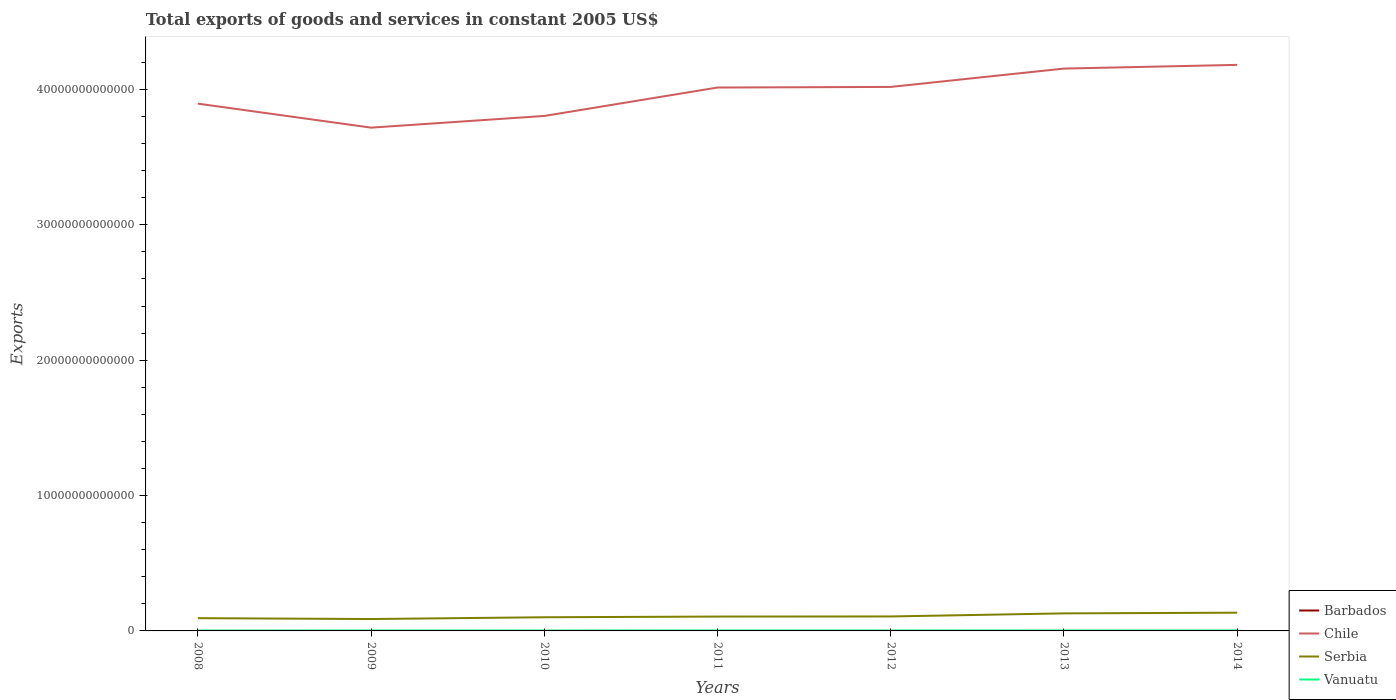Does the line corresponding to Vanuatu intersect with the line corresponding to Barbados?
Provide a short and direct response. No. Is the number of lines equal to the number of legend labels?
Offer a terse response. Yes. Across all years, what is the maximum total exports of goods and services in Barbados?
Make the answer very short. 5.80e+08. In which year was the total exports of goods and services in Barbados maximum?
Provide a short and direct response. 2013. What is the total total exports of goods and services in Barbados in the graph?
Provide a succinct answer. 1.68e+08. What is the difference between the highest and the second highest total exports of goods and services in Chile?
Your answer should be compact. 4.64e+12. Is the total exports of goods and services in Vanuatu strictly greater than the total exports of goods and services in Serbia over the years?
Offer a very short reply. Yes. How many lines are there?
Ensure brevity in your answer.  4. How many years are there in the graph?
Your answer should be compact. 7. What is the difference between two consecutive major ticks on the Y-axis?
Ensure brevity in your answer.  1.00e+13. How many legend labels are there?
Provide a short and direct response. 4. What is the title of the graph?
Your answer should be compact. Total exports of goods and services in constant 2005 US$. Does "Least developed countries" appear as one of the legend labels in the graph?
Give a very brief answer. No. What is the label or title of the Y-axis?
Your response must be concise. Exports. What is the Exports of Barbados in 2008?
Your response must be concise. 7.82e+08. What is the Exports of Chile in 2008?
Make the answer very short. 3.90e+13. What is the Exports of Serbia in 2008?
Provide a succinct answer. 9.43e+11. What is the Exports in Vanuatu in 2008?
Your answer should be very brief. 2.31e+1. What is the Exports in Barbados in 2009?
Ensure brevity in your answer.  7.59e+08. What is the Exports of Chile in 2009?
Offer a terse response. 3.72e+13. What is the Exports of Serbia in 2009?
Offer a terse response. 8.78e+11. What is the Exports of Vanuatu in 2009?
Offer a terse response. 2.64e+1. What is the Exports in Barbados in 2010?
Offer a terse response. 7.95e+08. What is the Exports in Chile in 2010?
Make the answer very short. 3.80e+13. What is the Exports in Serbia in 2010?
Make the answer very short. 1.01e+12. What is the Exports in Vanuatu in 2010?
Offer a very short reply. 2.65e+1. What is the Exports of Barbados in 2011?
Your answer should be compact. 6.14e+08. What is the Exports of Chile in 2011?
Provide a succinct answer. 4.01e+13. What is the Exports in Serbia in 2011?
Give a very brief answer. 1.06e+12. What is the Exports in Vanuatu in 2011?
Your response must be concise. 2.92e+1. What is the Exports in Barbados in 2012?
Your answer should be very brief. 6.13e+08. What is the Exports in Chile in 2012?
Give a very brief answer. 4.02e+13. What is the Exports of Serbia in 2012?
Ensure brevity in your answer.  1.07e+12. What is the Exports in Vanuatu in 2012?
Offer a terse response. 2.89e+1. What is the Exports in Barbados in 2013?
Provide a succinct answer. 5.80e+08. What is the Exports of Chile in 2013?
Your answer should be very brief. 4.15e+13. What is the Exports in Serbia in 2013?
Give a very brief answer. 1.30e+12. What is the Exports in Vanuatu in 2013?
Make the answer very short. 3.01e+1. What is the Exports in Barbados in 2014?
Ensure brevity in your answer.  5.84e+08. What is the Exports in Chile in 2014?
Give a very brief answer. 4.18e+13. What is the Exports of Serbia in 2014?
Make the answer very short. 1.35e+12. What is the Exports of Vanuatu in 2014?
Offer a very short reply. 2.99e+1. Across all years, what is the maximum Exports in Barbados?
Ensure brevity in your answer.  7.95e+08. Across all years, what is the maximum Exports of Chile?
Offer a very short reply. 4.18e+13. Across all years, what is the maximum Exports of Serbia?
Your answer should be very brief. 1.35e+12. Across all years, what is the maximum Exports in Vanuatu?
Provide a succinct answer. 3.01e+1. Across all years, what is the minimum Exports of Barbados?
Offer a terse response. 5.80e+08. Across all years, what is the minimum Exports of Chile?
Your response must be concise. 3.72e+13. Across all years, what is the minimum Exports of Serbia?
Your answer should be compact. 8.78e+11. Across all years, what is the minimum Exports of Vanuatu?
Your answer should be compact. 2.31e+1. What is the total Exports in Barbados in the graph?
Ensure brevity in your answer.  4.73e+09. What is the total Exports of Chile in the graph?
Provide a succinct answer. 2.78e+14. What is the total Exports of Serbia in the graph?
Ensure brevity in your answer.  7.61e+12. What is the total Exports of Vanuatu in the graph?
Your answer should be very brief. 1.94e+11. What is the difference between the Exports in Barbados in 2008 and that in 2009?
Your answer should be compact. 2.30e+07. What is the difference between the Exports of Chile in 2008 and that in 2009?
Keep it short and to the point. 1.77e+12. What is the difference between the Exports in Serbia in 2008 and that in 2009?
Ensure brevity in your answer.  6.49e+1. What is the difference between the Exports in Vanuatu in 2008 and that in 2009?
Give a very brief answer. -3.32e+09. What is the difference between the Exports of Barbados in 2008 and that in 2010?
Ensure brevity in your answer.  -1.30e+07. What is the difference between the Exports in Chile in 2008 and that in 2010?
Ensure brevity in your answer.  9.08e+11. What is the difference between the Exports of Serbia in 2008 and that in 2010?
Ensure brevity in your answer.  -6.69e+1. What is the difference between the Exports in Vanuatu in 2008 and that in 2010?
Give a very brief answer. -3.43e+09. What is the difference between the Exports of Barbados in 2008 and that in 2011?
Make the answer very short. 1.68e+08. What is the difference between the Exports of Chile in 2008 and that in 2011?
Offer a terse response. -1.19e+12. What is the difference between the Exports of Serbia in 2008 and that in 2011?
Provide a succinct answer. -1.17e+11. What is the difference between the Exports in Vanuatu in 2008 and that in 2011?
Make the answer very short. -6.19e+09. What is the difference between the Exports of Barbados in 2008 and that in 2012?
Your response must be concise. 1.69e+08. What is the difference between the Exports in Chile in 2008 and that in 2012?
Provide a short and direct response. -1.24e+12. What is the difference between the Exports in Serbia in 2008 and that in 2012?
Provide a succinct answer. -1.26e+11. What is the difference between the Exports in Vanuatu in 2008 and that in 2012?
Keep it short and to the point. -5.82e+09. What is the difference between the Exports in Barbados in 2008 and that in 2013?
Give a very brief answer. 2.02e+08. What is the difference between the Exports of Chile in 2008 and that in 2013?
Give a very brief answer. -2.59e+12. What is the difference between the Exports of Serbia in 2008 and that in 2013?
Your answer should be compact. -3.53e+11. What is the difference between the Exports of Vanuatu in 2008 and that in 2013?
Offer a terse response. -7.02e+09. What is the difference between the Exports of Barbados in 2008 and that in 2014?
Offer a very short reply. 1.98e+08. What is the difference between the Exports of Chile in 2008 and that in 2014?
Offer a terse response. -2.86e+12. What is the difference between the Exports in Serbia in 2008 and that in 2014?
Offer a very short reply. -4.04e+11. What is the difference between the Exports of Vanuatu in 2008 and that in 2014?
Offer a very short reply. -6.80e+09. What is the difference between the Exports of Barbados in 2009 and that in 2010?
Keep it short and to the point. -3.60e+07. What is the difference between the Exports of Chile in 2009 and that in 2010?
Your response must be concise. -8.64e+11. What is the difference between the Exports in Serbia in 2009 and that in 2010?
Your answer should be very brief. -1.32e+11. What is the difference between the Exports of Vanuatu in 2009 and that in 2010?
Provide a succinct answer. -1.09e+08. What is the difference between the Exports of Barbados in 2009 and that in 2011?
Give a very brief answer. 1.45e+08. What is the difference between the Exports of Chile in 2009 and that in 2011?
Offer a very short reply. -2.96e+12. What is the difference between the Exports of Serbia in 2009 and that in 2011?
Provide a short and direct response. -1.82e+11. What is the difference between the Exports in Vanuatu in 2009 and that in 2011?
Make the answer very short. -2.86e+09. What is the difference between the Exports of Barbados in 2009 and that in 2012?
Offer a terse response. 1.46e+08. What is the difference between the Exports in Chile in 2009 and that in 2012?
Make the answer very short. -3.01e+12. What is the difference between the Exports of Serbia in 2009 and that in 2012?
Provide a succinct answer. -1.91e+11. What is the difference between the Exports of Vanuatu in 2009 and that in 2012?
Provide a succinct answer. -2.50e+09. What is the difference between the Exports in Barbados in 2009 and that in 2013?
Your answer should be very brief. 1.79e+08. What is the difference between the Exports of Chile in 2009 and that in 2013?
Give a very brief answer. -4.36e+12. What is the difference between the Exports in Serbia in 2009 and that in 2013?
Give a very brief answer. -4.18e+11. What is the difference between the Exports of Vanuatu in 2009 and that in 2013?
Provide a succinct answer. -3.70e+09. What is the difference between the Exports in Barbados in 2009 and that in 2014?
Ensure brevity in your answer.  1.75e+08. What is the difference between the Exports in Chile in 2009 and that in 2014?
Your response must be concise. -4.64e+12. What is the difference between the Exports of Serbia in 2009 and that in 2014?
Give a very brief answer. -4.69e+11. What is the difference between the Exports in Vanuatu in 2009 and that in 2014?
Give a very brief answer. -3.48e+09. What is the difference between the Exports in Barbados in 2010 and that in 2011?
Your answer should be very brief. 1.81e+08. What is the difference between the Exports of Chile in 2010 and that in 2011?
Your answer should be very brief. -2.10e+12. What is the difference between the Exports of Serbia in 2010 and that in 2011?
Your answer should be very brief. -5.05e+1. What is the difference between the Exports of Vanuatu in 2010 and that in 2011?
Give a very brief answer. -2.76e+09. What is the difference between the Exports in Barbados in 2010 and that in 2012?
Give a very brief answer. 1.82e+08. What is the difference between the Exports in Chile in 2010 and that in 2012?
Your answer should be compact. -2.14e+12. What is the difference between the Exports of Serbia in 2010 and that in 2012?
Offer a terse response. -5.90e+1. What is the difference between the Exports in Vanuatu in 2010 and that in 2012?
Make the answer very short. -2.39e+09. What is the difference between the Exports of Barbados in 2010 and that in 2013?
Your answer should be compact. 2.15e+08. What is the difference between the Exports in Chile in 2010 and that in 2013?
Your answer should be very brief. -3.50e+12. What is the difference between the Exports of Serbia in 2010 and that in 2013?
Keep it short and to the point. -2.86e+11. What is the difference between the Exports in Vanuatu in 2010 and that in 2013?
Make the answer very short. -3.59e+09. What is the difference between the Exports in Barbados in 2010 and that in 2014?
Provide a short and direct response. 2.11e+08. What is the difference between the Exports of Chile in 2010 and that in 2014?
Offer a very short reply. -3.77e+12. What is the difference between the Exports in Serbia in 2010 and that in 2014?
Your response must be concise. -3.37e+11. What is the difference between the Exports of Vanuatu in 2010 and that in 2014?
Make the answer very short. -3.37e+09. What is the difference between the Exports in Barbados in 2011 and that in 2012?
Give a very brief answer. 1.00e+06. What is the difference between the Exports of Chile in 2011 and that in 2012?
Keep it short and to the point. -4.56e+1. What is the difference between the Exports of Serbia in 2011 and that in 2012?
Your answer should be compact. -8.49e+09. What is the difference between the Exports of Vanuatu in 2011 and that in 2012?
Make the answer very short. 3.63e+08. What is the difference between the Exports of Barbados in 2011 and that in 2013?
Ensure brevity in your answer.  3.40e+07. What is the difference between the Exports of Chile in 2011 and that in 2013?
Give a very brief answer. -1.40e+12. What is the difference between the Exports in Serbia in 2011 and that in 2013?
Make the answer very short. -2.36e+11. What is the difference between the Exports in Vanuatu in 2011 and that in 2013?
Your answer should be compact. -8.38e+08. What is the difference between the Exports of Barbados in 2011 and that in 2014?
Ensure brevity in your answer.  3.00e+07. What is the difference between the Exports in Chile in 2011 and that in 2014?
Your answer should be very brief. -1.67e+12. What is the difference between the Exports in Serbia in 2011 and that in 2014?
Provide a short and direct response. -2.86e+11. What is the difference between the Exports in Vanuatu in 2011 and that in 2014?
Your answer should be very brief. -6.13e+08. What is the difference between the Exports of Barbados in 2012 and that in 2013?
Ensure brevity in your answer.  3.30e+07. What is the difference between the Exports in Chile in 2012 and that in 2013?
Make the answer very short. -1.35e+12. What is the difference between the Exports of Serbia in 2012 and that in 2013?
Ensure brevity in your answer.  -2.27e+11. What is the difference between the Exports of Vanuatu in 2012 and that in 2013?
Keep it short and to the point. -1.20e+09. What is the difference between the Exports in Barbados in 2012 and that in 2014?
Your answer should be compact. 2.90e+07. What is the difference between the Exports of Chile in 2012 and that in 2014?
Your answer should be compact. -1.63e+12. What is the difference between the Exports of Serbia in 2012 and that in 2014?
Your response must be concise. -2.78e+11. What is the difference between the Exports in Vanuatu in 2012 and that in 2014?
Provide a succinct answer. -9.76e+08. What is the difference between the Exports of Barbados in 2013 and that in 2014?
Your answer should be compact. -4.00e+06. What is the difference between the Exports in Chile in 2013 and that in 2014?
Ensure brevity in your answer.  -2.73e+11. What is the difference between the Exports in Serbia in 2013 and that in 2014?
Keep it short and to the point. -5.05e+1. What is the difference between the Exports in Vanuatu in 2013 and that in 2014?
Provide a succinct answer. 2.25e+08. What is the difference between the Exports of Barbados in 2008 and the Exports of Chile in 2009?
Your answer should be compact. -3.72e+13. What is the difference between the Exports of Barbados in 2008 and the Exports of Serbia in 2009?
Keep it short and to the point. -8.77e+11. What is the difference between the Exports of Barbados in 2008 and the Exports of Vanuatu in 2009?
Give a very brief answer. -2.56e+1. What is the difference between the Exports in Chile in 2008 and the Exports in Serbia in 2009?
Keep it short and to the point. 3.81e+13. What is the difference between the Exports of Chile in 2008 and the Exports of Vanuatu in 2009?
Provide a short and direct response. 3.89e+13. What is the difference between the Exports in Serbia in 2008 and the Exports in Vanuatu in 2009?
Give a very brief answer. 9.17e+11. What is the difference between the Exports in Barbados in 2008 and the Exports in Chile in 2010?
Your answer should be compact. -3.80e+13. What is the difference between the Exports of Barbados in 2008 and the Exports of Serbia in 2010?
Provide a short and direct response. -1.01e+12. What is the difference between the Exports in Barbados in 2008 and the Exports in Vanuatu in 2010?
Your response must be concise. -2.57e+1. What is the difference between the Exports in Chile in 2008 and the Exports in Serbia in 2010?
Provide a short and direct response. 3.79e+13. What is the difference between the Exports of Chile in 2008 and the Exports of Vanuatu in 2010?
Your response must be concise. 3.89e+13. What is the difference between the Exports of Serbia in 2008 and the Exports of Vanuatu in 2010?
Your response must be concise. 9.17e+11. What is the difference between the Exports of Barbados in 2008 and the Exports of Chile in 2011?
Offer a very short reply. -4.01e+13. What is the difference between the Exports in Barbados in 2008 and the Exports in Serbia in 2011?
Your answer should be compact. -1.06e+12. What is the difference between the Exports of Barbados in 2008 and the Exports of Vanuatu in 2011?
Ensure brevity in your answer.  -2.85e+1. What is the difference between the Exports in Chile in 2008 and the Exports in Serbia in 2011?
Offer a very short reply. 3.79e+13. What is the difference between the Exports of Chile in 2008 and the Exports of Vanuatu in 2011?
Offer a very short reply. 3.89e+13. What is the difference between the Exports of Serbia in 2008 and the Exports of Vanuatu in 2011?
Give a very brief answer. 9.14e+11. What is the difference between the Exports in Barbados in 2008 and the Exports in Chile in 2012?
Provide a succinct answer. -4.02e+13. What is the difference between the Exports in Barbados in 2008 and the Exports in Serbia in 2012?
Keep it short and to the point. -1.07e+12. What is the difference between the Exports in Barbados in 2008 and the Exports in Vanuatu in 2012?
Offer a terse response. -2.81e+1. What is the difference between the Exports in Chile in 2008 and the Exports in Serbia in 2012?
Provide a succinct answer. 3.79e+13. What is the difference between the Exports of Chile in 2008 and the Exports of Vanuatu in 2012?
Provide a short and direct response. 3.89e+13. What is the difference between the Exports of Serbia in 2008 and the Exports of Vanuatu in 2012?
Make the answer very short. 9.14e+11. What is the difference between the Exports in Barbados in 2008 and the Exports in Chile in 2013?
Provide a succinct answer. -4.15e+13. What is the difference between the Exports in Barbados in 2008 and the Exports in Serbia in 2013?
Offer a very short reply. -1.30e+12. What is the difference between the Exports of Barbados in 2008 and the Exports of Vanuatu in 2013?
Your answer should be compact. -2.93e+1. What is the difference between the Exports of Chile in 2008 and the Exports of Serbia in 2013?
Your response must be concise. 3.77e+13. What is the difference between the Exports in Chile in 2008 and the Exports in Vanuatu in 2013?
Offer a terse response. 3.89e+13. What is the difference between the Exports of Serbia in 2008 and the Exports of Vanuatu in 2013?
Offer a terse response. 9.13e+11. What is the difference between the Exports of Barbados in 2008 and the Exports of Chile in 2014?
Offer a very short reply. -4.18e+13. What is the difference between the Exports in Barbados in 2008 and the Exports in Serbia in 2014?
Your answer should be compact. -1.35e+12. What is the difference between the Exports in Barbados in 2008 and the Exports in Vanuatu in 2014?
Offer a terse response. -2.91e+1. What is the difference between the Exports in Chile in 2008 and the Exports in Serbia in 2014?
Provide a succinct answer. 3.76e+13. What is the difference between the Exports of Chile in 2008 and the Exports of Vanuatu in 2014?
Provide a succinct answer. 3.89e+13. What is the difference between the Exports of Serbia in 2008 and the Exports of Vanuatu in 2014?
Your answer should be compact. 9.13e+11. What is the difference between the Exports in Barbados in 2009 and the Exports in Chile in 2010?
Provide a short and direct response. -3.80e+13. What is the difference between the Exports in Barbados in 2009 and the Exports in Serbia in 2010?
Offer a terse response. -1.01e+12. What is the difference between the Exports of Barbados in 2009 and the Exports of Vanuatu in 2010?
Your answer should be compact. -2.57e+1. What is the difference between the Exports in Chile in 2009 and the Exports in Serbia in 2010?
Offer a terse response. 3.62e+13. What is the difference between the Exports of Chile in 2009 and the Exports of Vanuatu in 2010?
Your answer should be compact. 3.72e+13. What is the difference between the Exports of Serbia in 2009 and the Exports of Vanuatu in 2010?
Offer a terse response. 8.52e+11. What is the difference between the Exports in Barbados in 2009 and the Exports in Chile in 2011?
Your response must be concise. -4.01e+13. What is the difference between the Exports in Barbados in 2009 and the Exports in Serbia in 2011?
Provide a succinct answer. -1.06e+12. What is the difference between the Exports in Barbados in 2009 and the Exports in Vanuatu in 2011?
Offer a terse response. -2.85e+1. What is the difference between the Exports in Chile in 2009 and the Exports in Serbia in 2011?
Ensure brevity in your answer.  3.61e+13. What is the difference between the Exports of Chile in 2009 and the Exports of Vanuatu in 2011?
Offer a terse response. 3.72e+13. What is the difference between the Exports of Serbia in 2009 and the Exports of Vanuatu in 2011?
Keep it short and to the point. 8.49e+11. What is the difference between the Exports of Barbados in 2009 and the Exports of Chile in 2012?
Your response must be concise. -4.02e+13. What is the difference between the Exports of Barbados in 2009 and the Exports of Serbia in 2012?
Offer a terse response. -1.07e+12. What is the difference between the Exports of Barbados in 2009 and the Exports of Vanuatu in 2012?
Your answer should be compact. -2.81e+1. What is the difference between the Exports in Chile in 2009 and the Exports in Serbia in 2012?
Make the answer very short. 3.61e+13. What is the difference between the Exports in Chile in 2009 and the Exports in Vanuatu in 2012?
Offer a terse response. 3.72e+13. What is the difference between the Exports of Serbia in 2009 and the Exports of Vanuatu in 2012?
Provide a short and direct response. 8.49e+11. What is the difference between the Exports of Barbados in 2009 and the Exports of Chile in 2013?
Your answer should be compact. -4.15e+13. What is the difference between the Exports in Barbados in 2009 and the Exports in Serbia in 2013?
Your response must be concise. -1.30e+12. What is the difference between the Exports of Barbados in 2009 and the Exports of Vanuatu in 2013?
Keep it short and to the point. -2.93e+1. What is the difference between the Exports of Chile in 2009 and the Exports of Serbia in 2013?
Offer a terse response. 3.59e+13. What is the difference between the Exports of Chile in 2009 and the Exports of Vanuatu in 2013?
Ensure brevity in your answer.  3.72e+13. What is the difference between the Exports of Serbia in 2009 and the Exports of Vanuatu in 2013?
Your response must be concise. 8.48e+11. What is the difference between the Exports in Barbados in 2009 and the Exports in Chile in 2014?
Offer a terse response. -4.18e+13. What is the difference between the Exports of Barbados in 2009 and the Exports of Serbia in 2014?
Keep it short and to the point. -1.35e+12. What is the difference between the Exports of Barbados in 2009 and the Exports of Vanuatu in 2014?
Give a very brief answer. -2.91e+1. What is the difference between the Exports in Chile in 2009 and the Exports in Serbia in 2014?
Provide a short and direct response. 3.58e+13. What is the difference between the Exports of Chile in 2009 and the Exports of Vanuatu in 2014?
Your answer should be compact. 3.72e+13. What is the difference between the Exports of Serbia in 2009 and the Exports of Vanuatu in 2014?
Provide a succinct answer. 8.48e+11. What is the difference between the Exports of Barbados in 2010 and the Exports of Chile in 2011?
Ensure brevity in your answer.  -4.01e+13. What is the difference between the Exports of Barbados in 2010 and the Exports of Serbia in 2011?
Offer a terse response. -1.06e+12. What is the difference between the Exports of Barbados in 2010 and the Exports of Vanuatu in 2011?
Your response must be concise. -2.84e+1. What is the difference between the Exports in Chile in 2010 and the Exports in Serbia in 2011?
Keep it short and to the point. 3.70e+13. What is the difference between the Exports in Chile in 2010 and the Exports in Vanuatu in 2011?
Ensure brevity in your answer.  3.80e+13. What is the difference between the Exports of Serbia in 2010 and the Exports of Vanuatu in 2011?
Keep it short and to the point. 9.81e+11. What is the difference between the Exports of Barbados in 2010 and the Exports of Chile in 2012?
Provide a succinct answer. -4.02e+13. What is the difference between the Exports of Barbados in 2010 and the Exports of Serbia in 2012?
Offer a very short reply. -1.07e+12. What is the difference between the Exports of Barbados in 2010 and the Exports of Vanuatu in 2012?
Offer a terse response. -2.81e+1. What is the difference between the Exports in Chile in 2010 and the Exports in Serbia in 2012?
Offer a very short reply. 3.70e+13. What is the difference between the Exports of Chile in 2010 and the Exports of Vanuatu in 2012?
Ensure brevity in your answer.  3.80e+13. What is the difference between the Exports in Serbia in 2010 and the Exports in Vanuatu in 2012?
Make the answer very short. 9.81e+11. What is the difference between the Exports of Barbados in 2010 and the Exports of Chile in 2013?
Provide a short and direct response. -4.15e+13. What is the difference between the Exports of Barbados in 2010 and the Exports of Serbia in 2013?
Ensure brevity in your answer.  -1.30e+12. What is the difference between the Exports of Barbados in 2010 and the Exports of Vanuatu in 2013?
Provide a succinct answer. -2.93e+1. What is the difference between the Exports in Chile in 2010 and the Exports in Serbia in 2013?
Your answer should be very brief. 3.67e+13. What is the difference between the Exports of Chile in 2010 and the Exports of Vanuatu in 2013?
Make the answer very short. 3.80e+13. What is the difference between the Exports of Serbia in 2010 and the Exports of Vanuatu in 2013?
Your answer should be compact. 9.80e+11. What is the difference between the Exports of Barbados in 2010 and the Exports of Chile in 2014?
Give a very brief answer. -4.18e+13. What is the difference between the Exports of Barbados in 2010 and the Exports of Serbia in 2014?
Give a very brief answer. -1.35e+12. What is the difference between the Exports in Barbados in 2010 and the Exports in Vanuatu in 2014?
Offer a very short reply. -2.91e+1. What is the difference between the Exports in Chile in 2010 and the Exports in Serbia in 2014?
Offer a terse response. 3.67e+13. What is the difference between the Exports of Chile in 2010 and the Exports of Vanuatu in 2014?
Offer a terse response. 3.80e+13. What is the difference between the Exports in Serbia in 2010 and the Exports in Vanuatu in 2014?
Offer a very short reply. 9.80e+11. What is the difference between the Exports of Barbados in 2011 and the Exports of Chile in 2012?
Give a very brief answer. -4.02e+13. What is the difference between the Exports in Barbados in 2011 and the Exports in Serbia in 2012?
Ensure brevity in your answer.  -1.07e+12. What is the difference between the Exports in Barbados in 2011 and the Exports in Vanuatu in 2012?
Keep it short and to the point. -2.83e+1. What is the difference between the Exports of Chile in 2011 and the Exports of Serbia in 2012?
Offer a terse response. 3.91e+13. What is the difference between the Exports in Chile in 2011 and the Exports in Vanuatu in 2012?
Provide a short and direct response. 4.01e+13. What is the difference between the Exports in Serbia in 2011 and the Exports in Vanuatu in 2012?
Give a very brief answer. 1.03e+12. What is the difference between the Exports in Barbados in 2011 and the Exports in Chile in 2013?
Give a very brief answer. -4.15e+13. What is the difference between the Exports of Barbados in 2011 and the Exports of Serbia in 2013?
Offer a terse response. -1.30e+12. What is the difference between the Exports in Barbados in 2011 and the Exports in Vanuatu in 2013?
Offer a very short reply. -2.95e+1. What is the difference between the Exports in Chile in 2011 and the Exports in Serbia in 2013?
Make the answer very short. 3.88e+13. What is the difference between the Exports in Chile in 2011 and the Exports in Vanuatu in 2013?
Offer a terse response. 4.01e+13. What is the difference between the Exports in Serbia in 2011 and the Exports in Vanuatu in 2013?
Your answer should be very brief. 1.03e+12. What is the difference between the Exports of Barbados in 2011 and the Exports of Chile in 2014?
Keep it short and to the point. -4.18e+13. What is the difference between the Exports of Barbados in 2011 and the Exports of Serbia in 2014?
Offer a terse response. -1.35e+12. What is the difference between the Exports of Barbados in 2011 and the Exports of Vanuatu in 2014?
Keep it short and to the point. -2.92e+1. What is the difference between the Exports in Chile in 2011 and the Exports in Serbia in 2014?
Your response must be concise. 3.88e+13. What is the difference between the Exports in Chile in 2011 and the Exports in Vanuatu in 2014?
Provide a succinct answer. 4.01e+13. What is the difference between the Exports in Serbia in 2011 and the Exports in Vanuatu in 2014?
Your answer should be compact. 1.03e+12. What is the difference between the Exports of Barbados in 2012 and the Exports of Chile in 2013?
Your answer should be compact. -4.15e+13. What is the difference between the Exports of Barbados in 2012 and the Exports of Serbia in 2013?
Provide a short and direct response. -1.30e+12. What is the difference between the Exports of Barbados in 2012 and the Exports of Vanuatu in 2013?
Your response must be concise. -2.95e+1. What is the difference between the Exports in Chile in 2012 and the Exports in Serbia in 2013?
Keep it short and to the point. 3.89e+13. What is the difference between the Exports in Chile in 2012 and the Exports in Vanuatu in 2013?
Your response must be concise. 4.02e+13. What is the difference between the Exports of Serbia in 2012 and the Exports of Vanuatu in 2013?
Make the answer very short. 1.04e+12. What is the difference between the Exports of Barbados in 2012 and the Exports of Chile in 2014?
Your answer should be very brief. -4.18e+13. What is the difference between the Exports of Barbados in 2012 and the Exports of Serbia in 2014?
Offer a very short reply. -1.35e+12. What is the difference between the Exports in Barbados in 2012 and the Exports in Vanuatu in 2014?
Offer a terse response. -2.92e+1. What is the difference between the Exports of Chile in 2012 and the Exports of Serbia in 2014?
Offer a terse response. 3.88e+13. What is the difference between the Exports of Chile in 2012 and the Exports of Vanuatu in 2014?
Give a very brief answer. 4.02e+13. What is the difference between the Exports in Serbia in 2012 and the Exports in Vanuatu in 2014?
Your answer should be compact. 1.04e+12. What is the difference between the Exports in Barbados in 2013 and the Exports in Chile in 2014?
Your answer should be very brief. -4.18e+13. What is the difference between the Exports of Barbados in 2013 and the Exports of Serbia in 2014?
Give a very brief answer. -1.35e+12. What is the difference between the Exports in Barbados in 2013 and the Exports in Vanuatu in 2014?
Ensure brevity in your answer.  -2.93e+1. What is the difference between the Exports in Chile in 2013 and the Exports in Serbia in 2014?
Your response must be concise. 4.02e+13. What is the difference between the Exports of Chile in 2013 and the Exports of Vanuatu in 2014?
Your answer should be compact. 4.15e+13. What is the difference between the Exports of Serbia in 2013 and the Exports of Vanuatu in 2014?
Ensure brevity in your answer.  1.27e+12. What is the average Exports in Barbados per year?
Keep it short and to the point. 6.75e+08. What is the average Exports in Chile per year?
Your answer should be compact. 3.97e+13. What is the average Exports of Serbia per year?
Provide a short and direct response. 1.09e+12. What is the average Exports in Vanuatu per year?
Make the answer very short. 2.77e+1. In the year 2008, what is the difference between the Exports in Barbados and Exports in Chile?
Offer a very short reply. -3.90e+13. In the year 2008, what is the difference between the Exports of Barbados and Exports of Serbia?
Give a very brief answer. -9.42e+11. In the year 2008, what is the difference between the Exports in Barbados and Exports in Vanuatu?
Ensure brevity in your answer.  -2.23e+1. In the year 2008, what is the difference between the Exports of Chile and Exports of Serbia?
Provide a short and direct response. 3.80e+13. In the year 2008, what is the difference between the Exports in Chile and Exports in Vanuatu?
Your response must be concise. 3.89e+13. In the year 2008, what is the difference between the Exports in Serbia and Exports in Vanuatu?
Offer a terse response. 9.20e+11. In the year 2009, what is the difference between the Exports in Barbados and Exports in Chile?
Your answer should be compact. -3.72e+13. In the year 2009, what is the difference between the Exports in Barbados and Exports in Serbia?
Your answer should be very brief. -8.78e+11. In the year 2009, what is the difference between the Exports of Barbados and Exports of Vanuatu?
Provide a succinct answer. -2.56e+1. In the year 2009, what is the difference between the Exports in Chile and Exports in Serbia?
Provide a succinct answer. 3.63e+13. In the year 2009, what is the difference between the Exports of Chile and Exports of Vanuatu?
Offer a terse response. 3.72e+13. In the year 2009, what is the difference between the Exports of Serbia and Exports of Vanuatu?
Make the answer very short. 8.52e+11. In the year 2010, what is the difference between the Exports in Barbados and Exports in Chile?
Offer a terse response. -3.80e+13. In the year 2010, what is the difference between the Exports in Barbados and Exports in Serbia?
Keep it short and to the point. -1.01e+12. In the year 2010, what is the difference between the Exports in Barbados and Exports in Vanuatu?
Offer a very short reply. -2.57e+1. In the year 2010, what is the difference between the Exports in Chile and Exports in Serbia?
Keep it short and to the point. 3.70e+13. In the year 2010, what is the difference between the Exports of Chile and Exports of Vanuatu?
Your answer should be very brief. 3.80e+13. In the year 2010, what is the difference between the Exports in Serbia and Exports in Vanuatu?
Give a very brief answer. 9.84e+11. In the year 2011, what is the difference between the Exports of Barbados and Exports of Chile?
Keep it short and to the point. -4.01e+13. In the year 2011, what is the difference between the Exports of Barbados and Exports of Serbia?
Your answer should be compact. -1.06e+12. In the year 2011, what is the difference between the Exports of Barbados and Exports of Vanuatu?
Offer a very short reply. -2.86e+1. In the year 2011, what is the difference between the Exports in Chile and Exports in Serbia?
Your response must be concise. 3.91e+13. In the year 2011, what is the difference between the Exports in Chile and Exports in Vanuatu?
Your answer should be compact. 4.01e+13. In the year 2011, what is the difference between the Exports in Serbia and Exports in Vanuatu?
Offer a terse response. 1.03e+12. In the year 2012, what is the difference between the Exports of Barbados and Exports of Chile?
Offer a very short reply. -4.02e+13. In the year 2012, what is the difference between the Exports of Barbados and Exports of Serbia?
Provide a short and direct response. -1.07e+12. In the year 2012, what is the difference between the Exports of Barbados and Exports of Vanuatu?
Keep it short and to the point. -2.83e+1. In the year 2012, what is the difference between the Exports of Chile and Exports of Serbia?
Provide a short and direct response. 3.91e+13. In the year 2012, what is the difference between the Exports in Chile and Exports in Vanuatu?
Provide a succinct answer. 4.02e+13. In the year 2012, what is the difference between the Exports in Serbia and Exports in Vanuatu?
Offer a very short reply. 1.04e+12. In the year 2013, what is the difference between the Exports of Barbados and Exports of Chile?
Your answer should be compact. -4.15e+13. In the year 2013, what is the difference between the Exports in Barbados and Exports in Serbia?
Offer a terse response. -1.30e+12. In the year 2013, what is the difference between the Exports of Barbados and Exports of Vanuatu?
Make the answer very short. -2.95e+1. In the year 2013, what is the difference between the Exports in Chile and Exports in Serbia?
Provide a succinct answer. 4.02e+13. In the year 2013, what is the difference between the Exports in Chile and Exports in Vanuatu?
Provide a short and direct response. 4.15e+13. In the year 2013, what is the difference between the Exports of Serbia and Exports of Vanuatu?
Your response must be concise. 1.27e+12. In the year 2014, what is the difference between the Exports in Barbados and Exports in Chile?
Provide a short and direct response. -4.18e+13. In the year 2014, what is the difference between the Exports of Barbados and Exports of Serbia?
Make the answer very short. -1.35e+12. In the year 2014, what is the difference between the Exports in Barbados and Exports in Vanuatu?
Offer a terse response. -2.93e+1. In the year 2014, what is the difference between the Exports of Chile and Exports of Serbia?
Ensure brevity in your answer.  4.05e+13. In the year 2014, what is the difference between the Exports of Chile and Exports of Vanuatu?
Your response must be concise. 4.18e+13. In the year 2014, what is the difference between the Exports of Serbia and Exports of Vanuatu?
Your answer should be very brief. 1.32e+12. What is the ratio of the Exports of Barbados in 2008 to that in 2009?
Your answer should be compact. 1.03. What is the ratio of the Exports in Chile in 2008 to that in 2009?
Give a very brief answer. 1.05. What is the ratio of the Exports of Serbia in 2008 to that in 2009?
Keep it short and to the point. 1.07. What is the ratio of the Exports of Vanuatu in 2008 to that in 2009?
Keep it short and to the point. 0.87. What is the ratio of the Exports in Barbados in 2008 to that in 2010?
Offer a terse response. 0.98. What is the ratio of the Exports in Chile in 2008 to that in 2010?
Ensure brevity in your answer.  1.02. What is the ratio of the Exports of Serbia in 2008 to that in 2010?
Your answer should be very brief. 0.93. What is the ratio of the Exports in Vanuatu in 2008 to that in 2010?
Provide a short and direct response. 0.87. What is the ratio of the Exports in Barbados in 2008 to that in 2011?
Make the answer very short. 1.27. What is the ratio of the Exports of Chile in 2008 to that in 2011?
Your answer should be compact. 0.97. What is the ratio of the Exports of Serbia in 2008 to that in 2011?
Give a very brief answer. 0.89. What is the ratio of the Exports in Vanuatu in 2008 to that in 2011?
Keep it short and to the point. 0.79. What is the ratio of the Exports of Barbados in 2008 to that in 2012?
Give a very brief answer. 1.28. What is the ratio of the Exports of Chile in 2008 to that in 2012?
Make the answer very short. 0.97. What is the ratio of the Exports in Serbia in 2008 to that in 2012?
Provide a short and direct response. 0.88. What is the ratio of the Exports in Vanuatu in 2008 to that in 2012?
Offer a very short reply. 0.8. What is the ratio of the Exports of Barbados in 2008 to that in 2013?
Give a very brief answer. 1.35. What is the ratio of the Exports of Chile in 2008 to that in 2013?
Your answer should be compact. 0.94. What is the ratio of the Exports of Serbia in 2008 to that in 2013?
Ensure brevity in your answer.  0.73. What is the ratio of the Exports in Vanuatu in 2008 to that in 2013?
Make the answer very short. 0.77. What is the ratio of the Exports in Barbados in 2008 to that in 2014?
Offer a very short reply. 1.34. What is the ratio of the Exports in Chile in 2008 to that in 2014?
Your answer should be compact. 0.93. What is the ratio of the Exports in Serbia in 2008 to that in 2014?
Give a very brief answer. 0.7. What is the ratio of the Exports of Vanuatu in 2008 to that in 2014?
Keep it short and to the point. 0.77. What is the ratio of the Exports of Barbados in 2009 to that in 2010?
Offer a terse response. 0.95. What is the ratio of the Exports in Chile in 2009 to that in 2010?
Your answer should be very brief. 0.98. What is the ratio of the Exports of Serbia in 2009 to that in 2010?
Offer a terse response. 0.87. What is the ratio of the Exports of Barbados in 2009 to that in 2011?
Ensure brevity in your answer.  1.24. What is the ratio of the Exports of Chile in 2009 to that in 2011?
Offer a terse response. 0.93. What is the ratio of the Exports in Serbia in 2009 to that in 2011?
Offer a very short reply. 0.83. What is the ratio of the Exports in Vanuatu in 2009 to that in 2011?
Your response must be concise. 0.9. What is the ratio of the Exports of Barbados in 2009 to that in 2012?
Offer a terse response. 1.24. What is the ratio of the Exports in Chile in 2009 to that in 2012?
Offer a terse response. 0.93. What is the ratio of the Exports in Serbia in 2009 to that in 2012?
Keep it short and to the point. 0.82. What is the ratio of the Exports of Vanuatu in 2009 to that in 2012?
Keep it short and to the point. 0.91. What is the ratio of the Exports in Barbados in 2009 to that in 2013?
Your response must be concise. 1.31. What is the ratio of the Exports of Chile in 2009 to that in 2013?
Offer a terse response. 0.9. What is the ratio of the Exports in Serbia in 2009 to that in 2013?
Make the answer very short. 0.68. What is the ratio of the Exports in Vanuatu in 2009 to that in 2013?
Keep it short and to the point. 0.88. What is the ratio of the Exports in Barbados in 2009 to that in 2014?
Your answer should be compact. 1.3. What is the ratio of the Exports of Chile in 2009 to that in 2014?
Your answer should be very brief. 0.89. What is the ratio of the Exports of Serbia in 2009 to that in 2014?
Offer a very short reply. 0.65. What is the ratio of the Exports in Vanuatu in 2009 to that in 2014?
Make the answer very short. 0.88. What is the ratio of the Exports of Barbados in 2010 to that in 2011?
Your answer should be very brief. 1.29. What is the ratio of the Exports in Chile in 2010 to that in 2011?
Ensure brevity in your answer.  0.95. What is the ratio of the Exports in Serbia in 2010 to that in 2011?
Provide a succinct answer. 0.95. What is the ratio of the Exports of Vanuatu in 2010 to that in 2011?
Keep it short and to the point. 0.91. What is the ratio of the Exports in Barbados in 2010 to that in 2012?
Provide a short and direct response. 1.3. What is the ratio of the Exports of Chile in 2010 to that in 2012?
Your answer should be very brief. 0.95. What is the ratio of the Exports in Serbia in 2010 to that in 2012?
Your response must be concise. 0.94. What is the ratio of the Exports in Vanuatu in 2010 to that in 2012?
Offer a terse response. 0.92. What is the ratio of the Exports in Barbados in 2010 to that in 2013?
Keep it short and to the point. 1.37. What is the ratio of the Exports in Chile in 2010 to that in 2013?
Your response must be concise. 0.92. What is the ratio of the Exports of Serbia in 2010 to that in 2013?
Your answer should be compact. 0.78. What is the ratio of the Exports of Vanuatu in 2010 to that in 2013?
Offer a terse response. 0.88. What is the ratio of the Exports of Barbados in 2010 to that in 2014?
Ensure brevity in your answer.  1.36. What is the ratio of the Exports in Chile in 2010 to that in 2014?
Your answer should be very brief. 0.91. What is the ratio of the Exports of Serbia in 2010 to that in 2014?
Make the answer very short. 0.75. What is the ratio of the Exports of Vanuatu in 2010 to that in 2014?
Make the answer very short. 0.89. What is the ratio of the Exports of Serbia in 2011 to that in 2012?
Your response must be concise. 0.99. What is the ratio of the Exports of Vanuatu in 2011 to that in 2012?
Ensure brevity in your answer.  1.01. What is the ratio of the Exports of Barbados in 2011 to that in 2013?
Your answer should be compact. 1.06. What is the ratio of the Exports in Chile in 2011 to that in 2013?
Provide a short and direct response. 0.97. What is the ratio of the Exports of Serbia in 2011 to that in 2013?
Ensure brevity in your answer.  0.82. What is the ratio of the Exports of Vanuatu in 2011 to that in 2013?
Keep it short and to the point. 0.97. What is the ratio of the Exports of Barbados in 2011 to that in 2014?
Give a very brief answer. 1.05. What is the ratio of the Exports in Serbia in 2011 to that in 2014?
Keep it short and to the point. 0.79. What is the ratio of the Exports in Vanuatu in 2011 to that in 2014?
Ensure brevity in your answer.  0.98. What is the ratio of the Exports in Barbados in 2012 to that in 2013?
Offer a terse response. 1.06. What is the ratio of the Exports of Chile in 2012 to that in 2013?
Offer a terse response. 0.97. What is the ratio of the Exports in Serbia in 2012 to that in 2013?
Your answer should be compact. 0.82. What is the ratio of the Exports in Vanuatu in 2012 to that in 2013?
Your answer should be very brief. 0.96. What is the ratio of the Exports of Barbados in 2012 to that in 2014?
Give a very brief answer. 1.05. What is the ratio of the Exports of Chile in 2012 to that in 2014?
Your answer should be very brief. 0.96. What is the ratio of the Exports of Serbia in 2012 to that in 2014?
Offer a very short reply. 0.79. What is the ratio of the Exports in Vanuatu in 2012 to that in 2014?
Provide a succinct answer. 0.97. What is the ratio of the Exports in Barbados in 2013 to that in 2014?
Your answer should be compact. 0.99. What is the ratio of the Exports in Serbia in 2013 to that in 2014?
Your answer should be compact. 0.96. What is the ratio of the Exports of Vanuatu in 2013 to that in 2014?
Offer a very short reply. 1.01. What is the difference between the highest and the second highest Exports of Barbados?
Provide a short and direct response. 1.30e+07. What is the difference between the highest and the second highest Exports in Chile?
Offer a very short reply. 2.73e+11. What is the difference between the highest and the second highest Exports of Serbia?
Make the answer very short. 5.05e+1. What is the difference between the highest and the second highest Exports of Vanuatu?
Your answer should be compact. 2.25e+08. What is the difference between the highest and the lowest Exports of Barbados?
Ensure brevity in your answer.  2.15e+08. What is the difference between the highest and the lowest Exports of Chile?
Offer a very short reply. 4.64e+12. What is the difference between the highest and the lowest Exports of Serbia?
Provide a succinct answer. 4.69e+11. What is the difference between the highest and the lowest Exports of Vanuatu?
Give a very brief answer. 7.02e+09. 